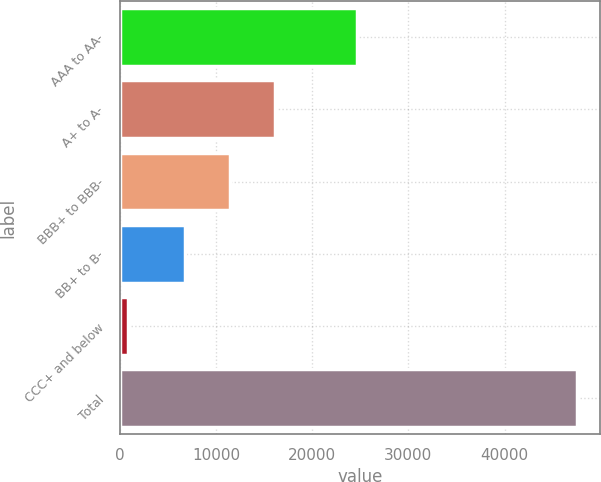Convert chart to OTSL. <chart><loc_0><loc_0><loc_500><loc_500><bar_chart><fcel>AAA to AA-<fcel>A+ to A-<fcel>BBB+ to BBB-<fcel>BB+ to B-<fcel>CCC+ and below<fcel>Total<nl><fcel>24697<fcel>16120<fcel>11448.5<fcel>6777<fcel>822<fcel>47537<nl></chart> 